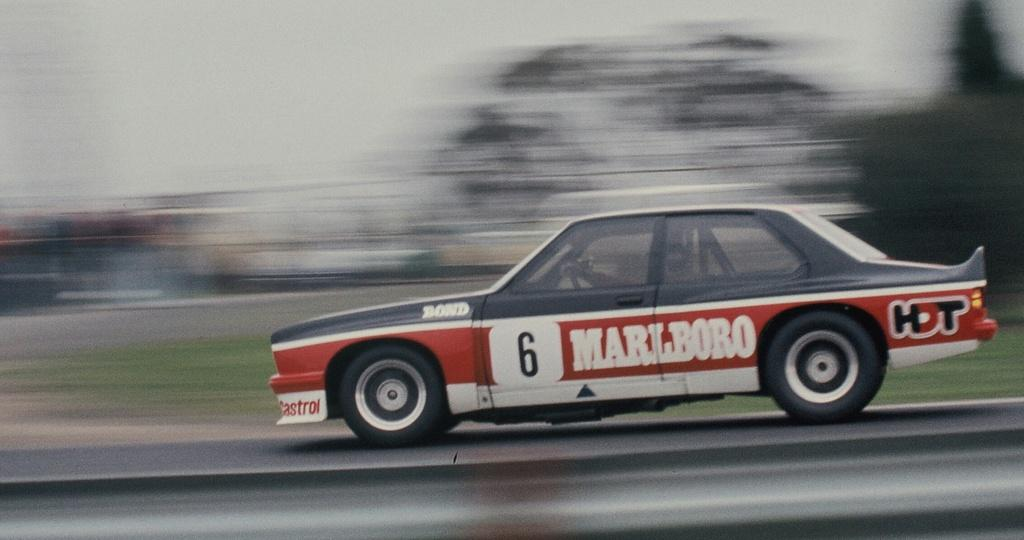What is the main subject of the image? There is a car on the road in the image. Who is operating the car? A person is driving the car. Can you describe the background of the image? The background of the image is blurred. What type of bat can be seen playing in the background of the image? There is no bat or any play-related activity visible in the image; the background is blurred. 